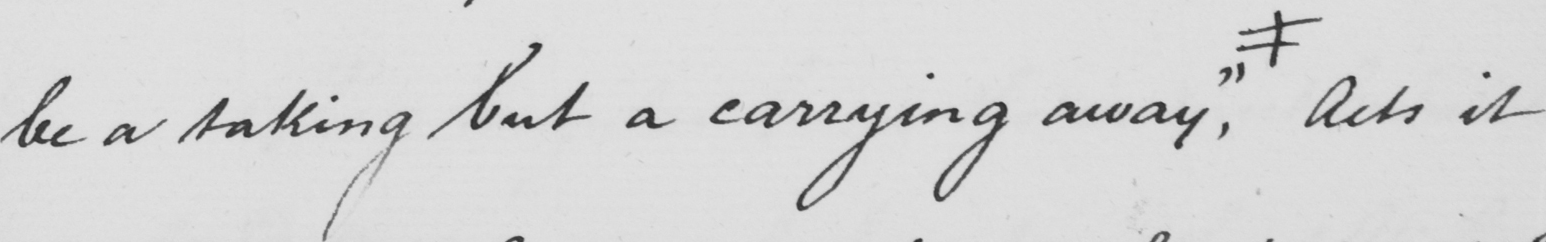Can you read and transcribe this handwriting? be a taking but a carrying away "  , # acts it 